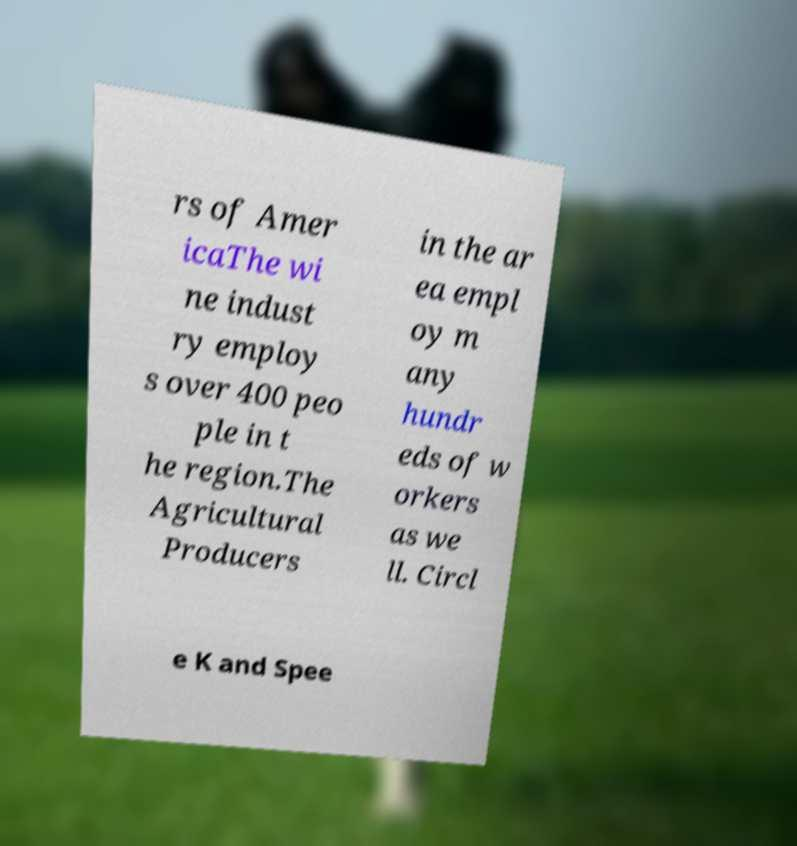There's text embedded in this image that I need extracted. Can you transcribe it verbatim? rs of Amer icaThe wi ne indust ry employ s over 400 peo ple in t he region.The Agricultural Producers in the ar ea empl oy m any hundr eds of w orkers as we ll. Circl e K and Spee 